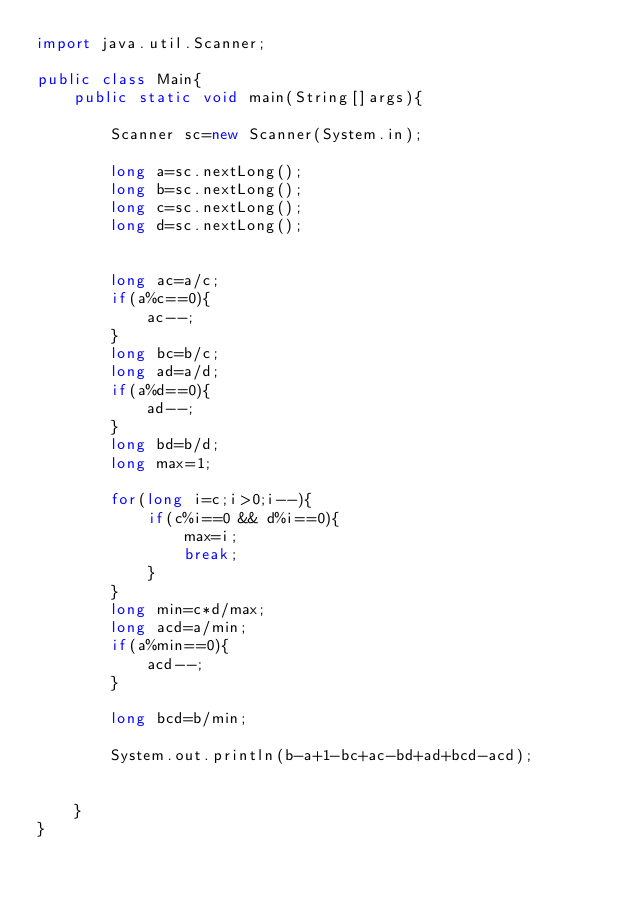<code> <loc_0><loc_0><loc_500><loc_500><_Java_>import java.util.Scanner;

public class Main{
	public static void main(String[]args){

		Scanner sc=new Scanner(System.in);

		long a=sc.nextLong();
		long b=sc.nextLong();
		long c=sc.nextLong();
		long d=sc.nextLong();


		long ac=a/c;
		if(a%c==0){
			ac--;
		}
		long bc=b/c;
		long ad=a/d;
		if(a%d==0){
			ad--;
		}
		long bd=b/d;
		long max=1;

		for(long i=c;i>0;i--){
			if(c%i==0 && d%i==0){
				max=i;
				break;
			}
		}
		long min=c*d/max;
		long acd=a/min;
		if(a%min==0){
			acd--;
		}

		long bcd=b/min;

		System.out.println(b-a+1-bc+ac-bd+ad+bcd-acd);


	}
}
</code> 